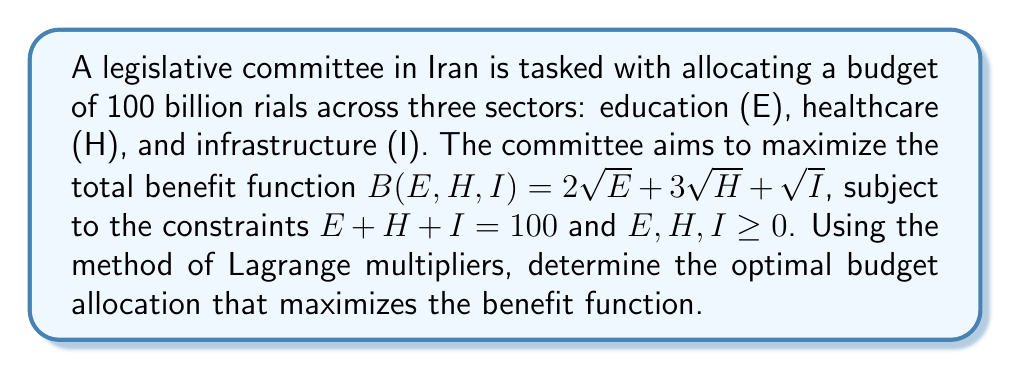Can you answer this question? To solve this constrained optimization problem, we'll use the method of Lagrange multipliers:

1) Define the Lagrangian function:
   $$L(E,H,I,\lambda) = 2\sqrt{E} + 3\sqrt{H} + \sqrt{I} - \lambda(E + H + I - 100)$$

2) Calculate partial derivatives and set them equal to zero:
   $$\frac{\partial L}{\partial E} = \frac{1}{\sqrt{E}} - \lambda = 0$$
   $$\frac{\partial L}{\partial H} = \frac{3}{2\sqrt{H}} - \lambda = 0$$
   $$\frac{\partial L}{\partial I} = \frac{1}{2\sqrt{I}} - \lambda = 0$$
   $$\frac{\partial L}{\partial \lambda} = E + H + I - 100 = 0$$

3) From these equations, we can deduce:
   $$\frac{1}{\sqrt{E}} = \frac{3}{2\sqrt{H}} = \frac{1}{2\sqrt{I}} = \lambda$$

4) This implies:
   $$\sqrt{E} = \frac{2}{3}\sqrt{H} = 2\sqrt{I}$$

5) Squaring both sides:
   $$E = \frac{4}{9}H = 4I$$

6) Substituting into the constraint equation:
   $$E + H + I = 100$$
   $$\frac{4}{9}H + H + \frac{1}{4}H = 100$$
   $$\frac{49}{36}H = 100$$
   $$H = \frac{3600}{49} \approx 73.47$$

7) Solving for E and I:
   $$E = \frac{4}{9}H = \frac{1600}{49} \approx 32.65$$
   $$I = \frac{1}{4}H = \frac{900}{49} \approx 18.37$$

8) Rounding to the nearest billion rials (as the budget is in billions):
   E = 33 billion rials
   H = 73 billion rials
   I = 18 billion rials
Answer: E = 33, H = 73, I = 18 (billion rials) 